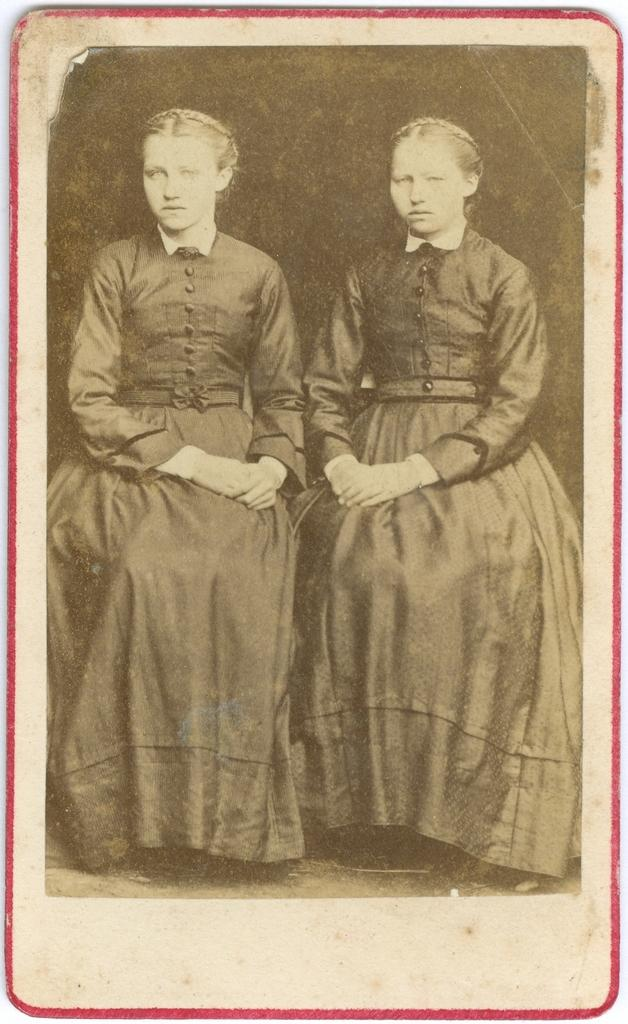What is the color scheme of the image? The image is black and white. How many people are visible in the image? There are two women sitting in the image. Can you describe any additional features of the image? The image appears to have a red border. What type of lettuce is on the plate in the image? There is no plate or lettuce present in the image; it is a black and white image of two women sitting with a red border. 